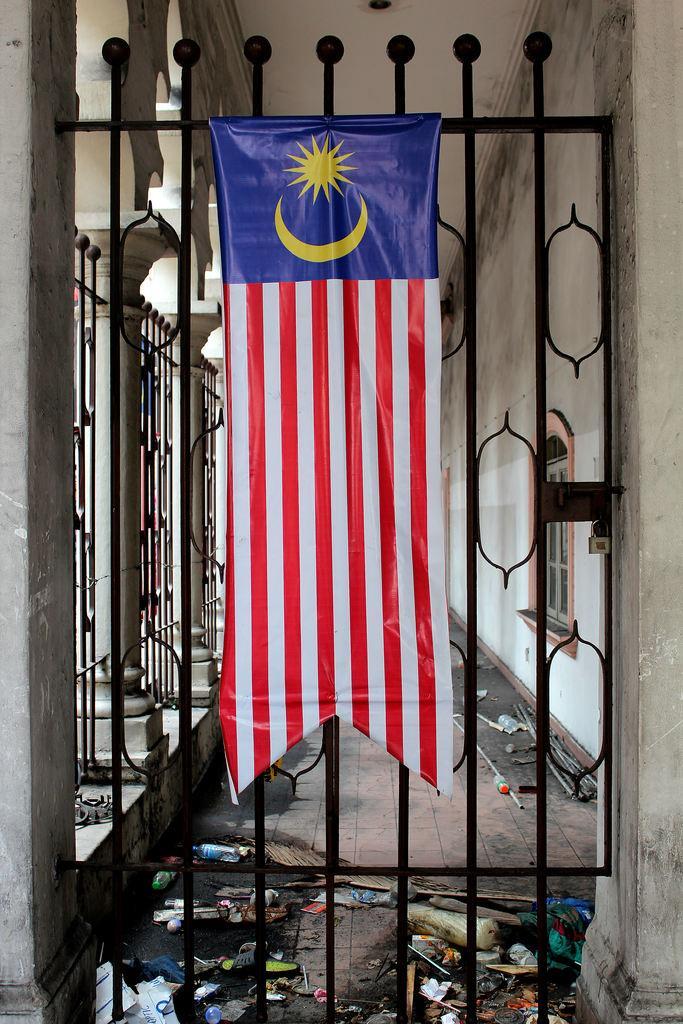Please provide a concise description of this image. This image is taken indoors. In this image there is a building with walls, windows and pillars. There is a railing and there are a few grills. In the middle of the image there is a flag on the gate. At the top of the image there is a ceiling. At the bottom of the image there is a floor and it is untidy. 